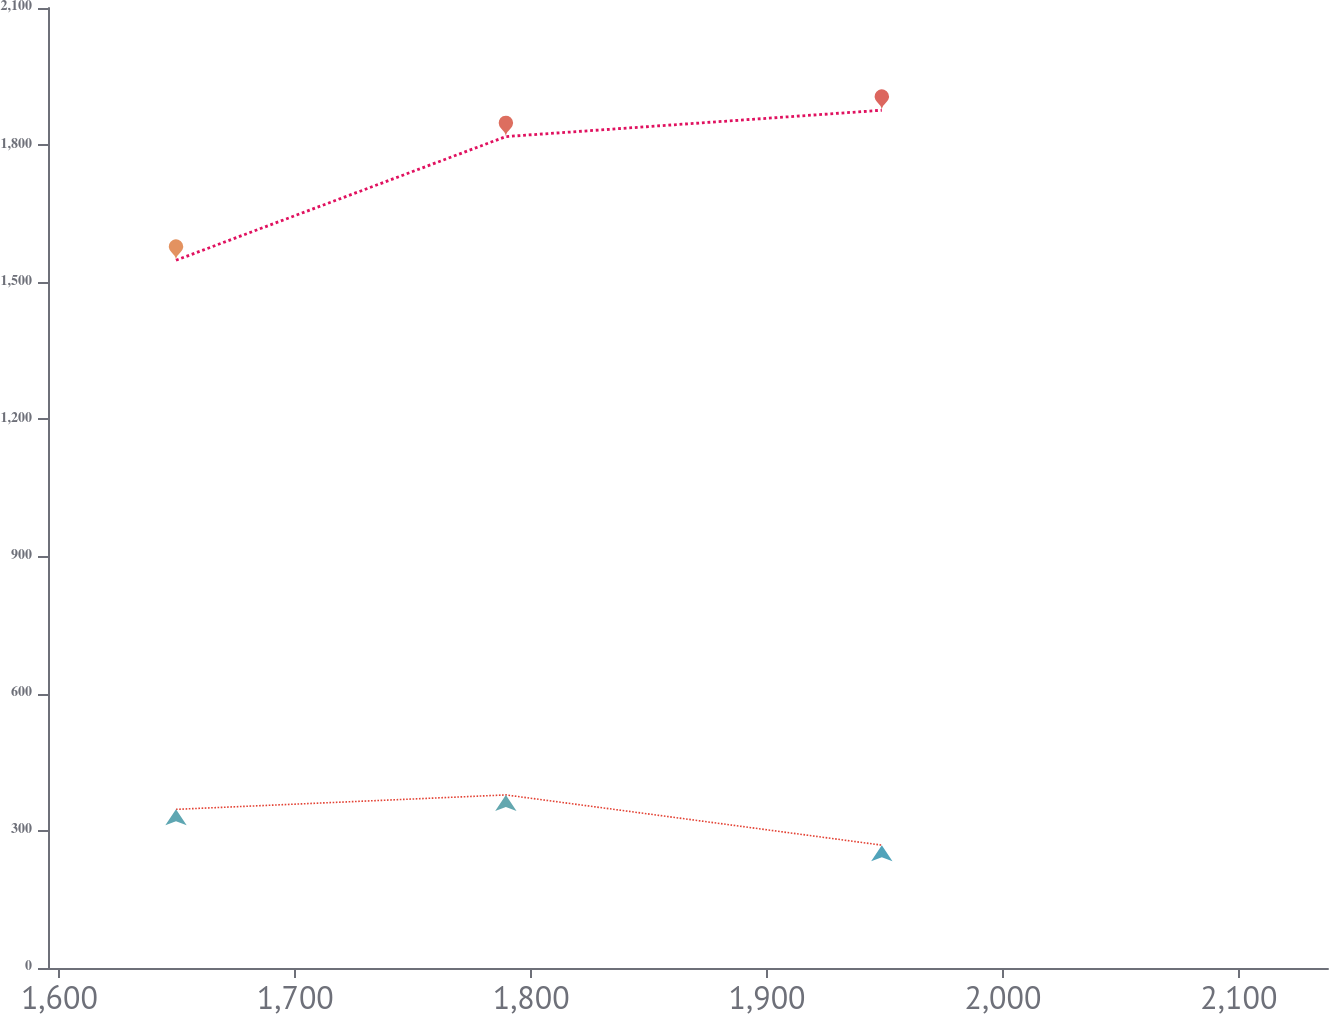Convert chart. <chart><loc_0><loc_0><loc_500><loc_500><line_chart><ecel><fcel>U.S.<fcel>International<nl><fcel>1649.43<fcel>1548.2<fcel>347.03<nl><fcel>1789.27<fcel>1818.77<fcel>378.62<nl><fcel>1948.65<fcel>1876.35<fcel>268.76<nl><fcel>2139.41<fcel>2051.87<fcel>369.24<nl><fcel>2192.06<fcel>1694.24<fcel>359.86<nl></chart> 